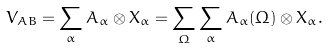<formula> <loc_0><loc_0><loc_500><loc_500>V _ { A B } = \sum _ { \alpha } A _ { \alpha } \otimes X _ { \alpha } = \sum _ { \Omega } \sum _ { \alpha } A _ { \alpha } ( \Omega ) \otimes X _ { \alpha } .</formula> 